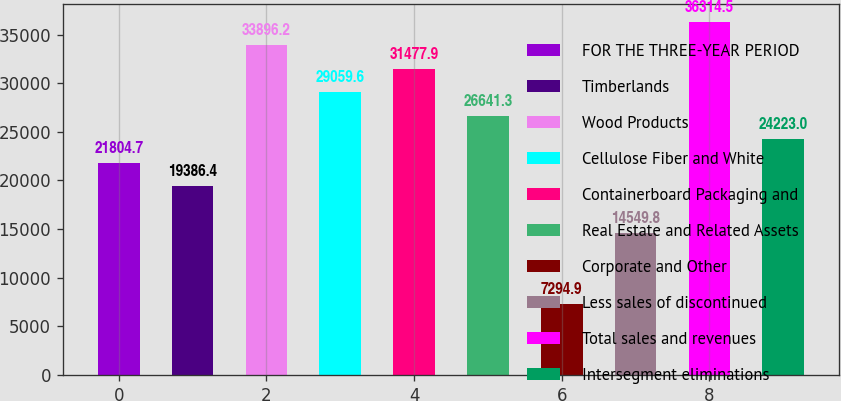Convert chart. <chart><loc_0><loc_0><loc_500><loc_500><bar_chart><fcel>FOR THE THREE-YEAR PERIOD<fcel>Timberlands<fcel>Wood Products<fcel>Cellulose Fiber and White<fcel>Containerboard Packaging and<fcel>Real Estate and Related Assets<fcel>Corporate and Other<fcel>Less sales of discontinued<fcel>Total sales and revenues<fcel>Intersegment eliminations<nl><fcel>21804.7<fcel>19386.4<fcel>33896.2<fcel>29059.6<fcel>31477.9<fcel>26641.3<fcel>7294.9<fcel>14549.8<fcel>36314.5<fcel>24223<nl></chart> 